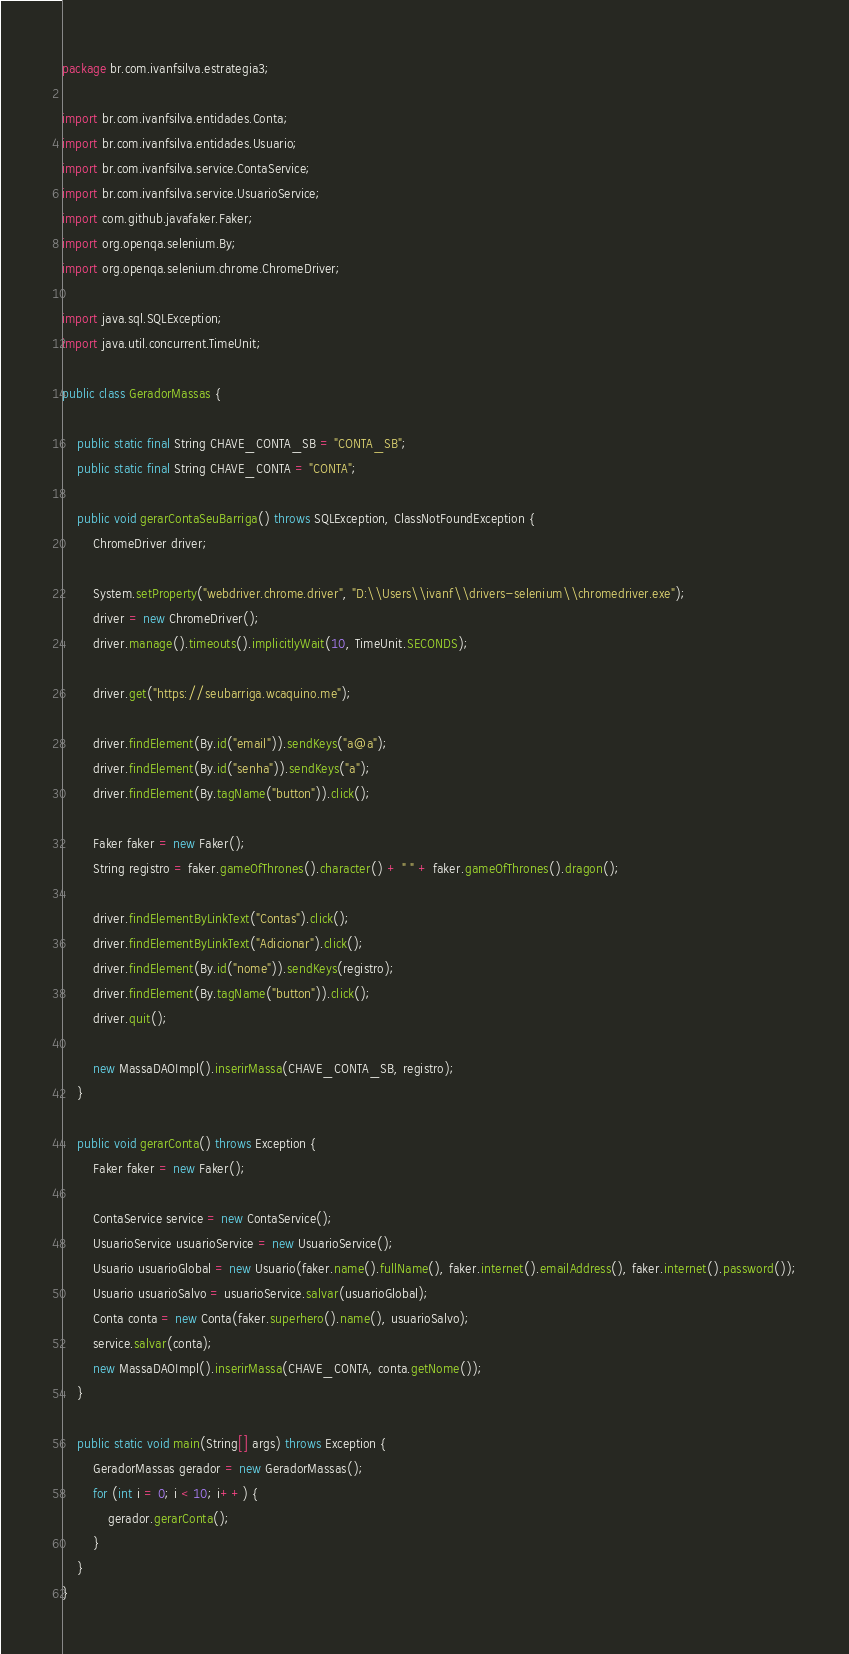Convert code to text. <code><loc_0><loc_0><loc_500><loc_500><_Java_>package br.com.ivanfsilva.estrategia3;

import br.com.ivanfsilva.entidades.Conta;
import br.com.ivanfsilva.entidades.Usuario;
import br.com.ivanfsilva.service.ContaService;
import br.com.ivanfsilva.service.UsuarioService;
import com.github.javafaker.Faker;
import org.openqa.selenium.By;
import org.openqa.selenium.chrome.ChromeDriver;

import java.sql.SQLException;
import java.util.concurrent.TimeUnit;

public class GeradorMassas {

    public static final String CHAVE_CONTA_SB = "CONTA_SB";
    public static final String CHAVE_CONTA = "CONTA";

    public void gerarContaSeuBarriga() throws SQLException, ClassNotFoundException {
        ChromeDriver driver;

        System.setProperty("webdriver.chrome.driver", "D:\\Users\\ivanf\\drivers-selenium\\chromedriver.exe");
        driver = new ChromeDriver();
        driver.manage().timeouts().implicitlyWait(10, TimeUnit.SECONDS);

        driver.get("https://seubarriga.wcaquino.me");

        driver.findElement(By.id("email")).sendKeys("a@a");
        driver.findElement(By.id("senha")).sendKeys("a");
        driver.findElement(By.tagName("button")).click();

        Faker faker = new Faker();
        String registro = faker.gameOfThrones().character() + " " + faker.gameOfThrones().dragon();

        driver.findElementByLinkText("Contas").click();
        driver.findElementByLinkText("Adicionar").click();
        driver.findElement(By.id("nome")).sendKeys(registro);
        driver.findElement(By.tagName("button")).click();
        driver.quit();

        new MassaDAOImpl().inserirMassa(CHAVE_CONTA_SB, registro);
    }

    public void gerarConta() throws Exception {
        Faker faker = new Faker();

        ContaService service = new ContaService();
        UsuarioService usuarioService = new UsuarioService();
        Usuario usuarioGlobal = new Usuario(faker.name().fullName(), faker.internet().emailAddress(), faker.internet().password());
        Usuario usuarioSalvo = usuarioService.salvar(usuarioGlobal);
        Conta conta = new Conta(faker.superhero().name(), usuarioSalvo);
        service.salvar(conta);
        new MassaDAOImpl().inserirMassa(CHAVE_CONTA, conta.getNome());
    }

    public static void main(String[] args) throws Exception {
        GeradorMassas gerador = new GeradorMassas();
        for (int i = 0; i < 10; i++) {
            gerador.gerarConta();
        }
    }
}
</code> 